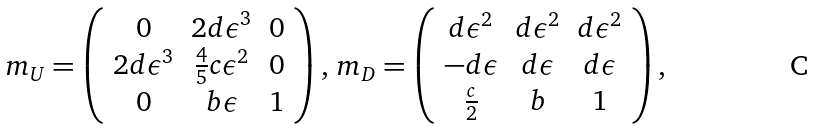Convert formula to latex. <formula><loc_0><loc_0><loc_500><loc_500>m _ { U } = \left ( \begin{array} { c c c } 0 & 2 d \epsilon ^ { 3 } & 0 \\ 2 d \epsilon ^ { 3 } & \frac { 4 } { 5 } c \epsilon ^ { 2 } & 0 \\ 0 & b \epsilon & 1 \\ \end{array} \right ) , \, m _ { D } = \left ( \begin{array} { c c c } d \epsilon ^ { 2 } & d \epsilon ^ { 2 } & d \epsilon ^ { 2 } \\ - d \epsilon & d \epsilon & d \epsilon \\ \frac { c } { 2 } & b & 1 \\ \end{array} \right ) ,</formula> 